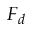Convert formula to latex. <formula><loc_0><loc_0><loc_500><loc_500>F _ { d }</formula> 